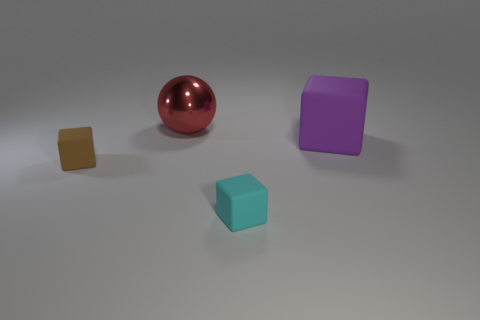Add 3 big yellow metal blocks. How many objects exist? 7 Subtract all spheres. How many objects are left? 3 Add 4 small brown rubber objects. How many small brown rubber objects are left? 5 Add 4 large red metallic objects. How many large red metallic objects exist? 5 Subtract 1 purple cubes. How many objects are left? 3 Subtract all brown matte things. Subtract all tiny cyan rubber blocks. How many objects are left? 2 